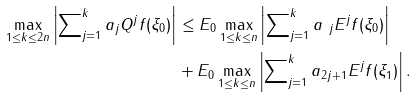Convert formula to latex. <formula><loc_0><loc_0><loc_500><loc_500>\max _ { 1 \leq k \leq 2 n } \left | \sum \nolimits _ { j = 1 } ^ { k } a _ { j } Q ^ { j } f ( \xi _ { 0 } ) \right | & \leq E _ { 0 } \max _ { 1 \leq k \leq n } \left | \sum \nolimits _ { j = 1 } ^ { k } a _ { \ j } E ^ { j } f ( \xi _ { 0 } ) \right | \\ & + E _ { 0 } \max _ { 1 \leq k \leq n } \left | \sum \nolimits _ { j = 1 } ^ { k } a _ { 2 j + 1 } E ^ { j } f ( \xi _ { 1 } ) \right | .</formula> 